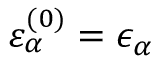Convert formula to latex. <formula><loc_0><loc_0><loc_500><loc_500>\varepsilon _ { \alpha } ^ { ( 0 ) } = \epsilon _ { \alpha }</formula> 